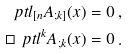Convert formula to latex. <formula><loc_0><loc_0><loc_500><loc_500>\ p t l _ { [ n } A _ { ; k ] } ( x ) = 0 \, , \\ \square \ p t l ^ { k } A _ { ; k } ( x ) = 0 \, .</formula> 